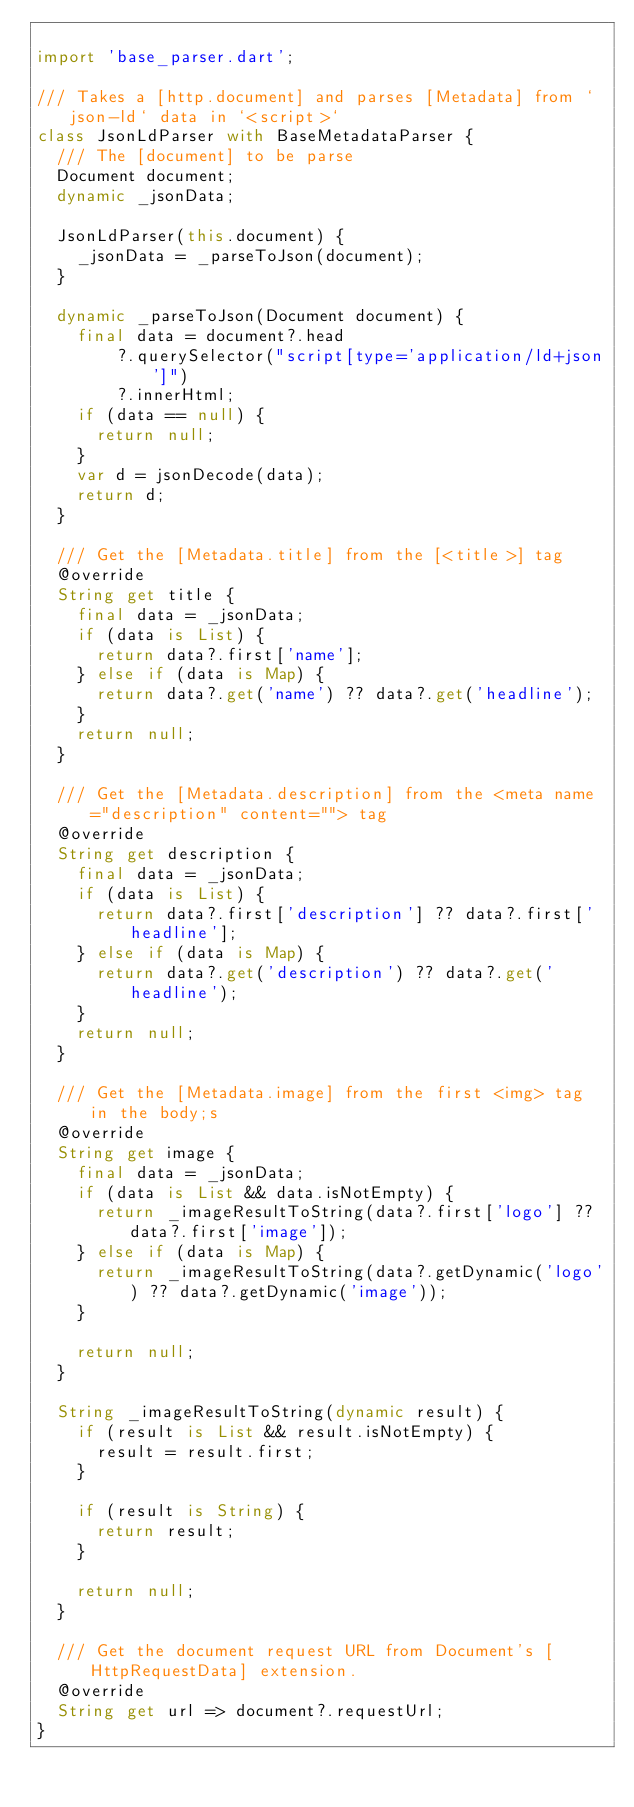Convert code to text. <code><loc_0><loc_0><loc_500><loc_500><_Dart_>
import 'base_parser.dart';

/// Takes a [http.document] and parses [Metadata] from `json-ld` data in `<script>`
class JsonLdParser with BaseMetadataParser {
  /// The [document] to be parse
  Document document;
  dynamic _jsonData;

  JsonLdParser(this.document) {
    _jsonData = _parseToJson(document);
  }

  dynamic _parseToJson(Document document) {
    final data = document?.head
        ?.querySelector("script[type='application/ld+json']")
        ?.innerHtml;
    if (data == null) {
      return null;
    }
    var d = jsonDecode(data);
    return d;
  }

  /// Get the [Metadata.title] from the [<title>] tag
  @override
  String get title {
    final data = _jsonData;
    if (data is List) {
      return data?.first['name'];
    } else if (data is Map) {
      return data?.get('name') ?? data?.get('headline');
    }
    return null;
  }

  /// Get the [Metadata.description] from the <meta name="description" content=""> tag
  @override
  String get description {
    final data = _jsonData;
    if (data is List) {
      return data?.first['description'] ?? data?.first['headline'];
    } else if (data is Map) {
      return data?.get('description') ?? data?.get('headline');
    }
    return null;
  }

  /// Get the [Metadata.image] from the first <img> tag in the body;s
  @override
  String get image {
    final data = _jsonData;
    if (data is List && data.isNotEmpty) {
      return _imageResultToString(data?.first['logo'] ?? data?.first['image']);
    } else if (data is Map) {
      return _imageResultToString(data?.getDynamic('logo') ?? data?.getDynamic('image'));
    }

    return null;
  }

  String _imageResultToString(dynamic result) {
    if (result is List && result.isNotEmpty) {
      result = result.first;
    }

    if (result is String) {
      return result;
    }

    return null;
  }

  /// Get the document request URL from Document's [HttpRequestData] extension.
  @override
  String get url => document?.requestUrl;
}
</code> 